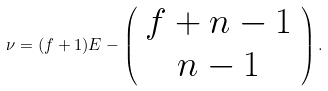Convert formula to latex. <formula><loc_0><loc_0><loc_500><loc_500>\nu = ( f + 1 ) E - \left ( \begin{array} { c c } f + n - 1 \\ n - 1 \end{array} \right ) .</formula> 